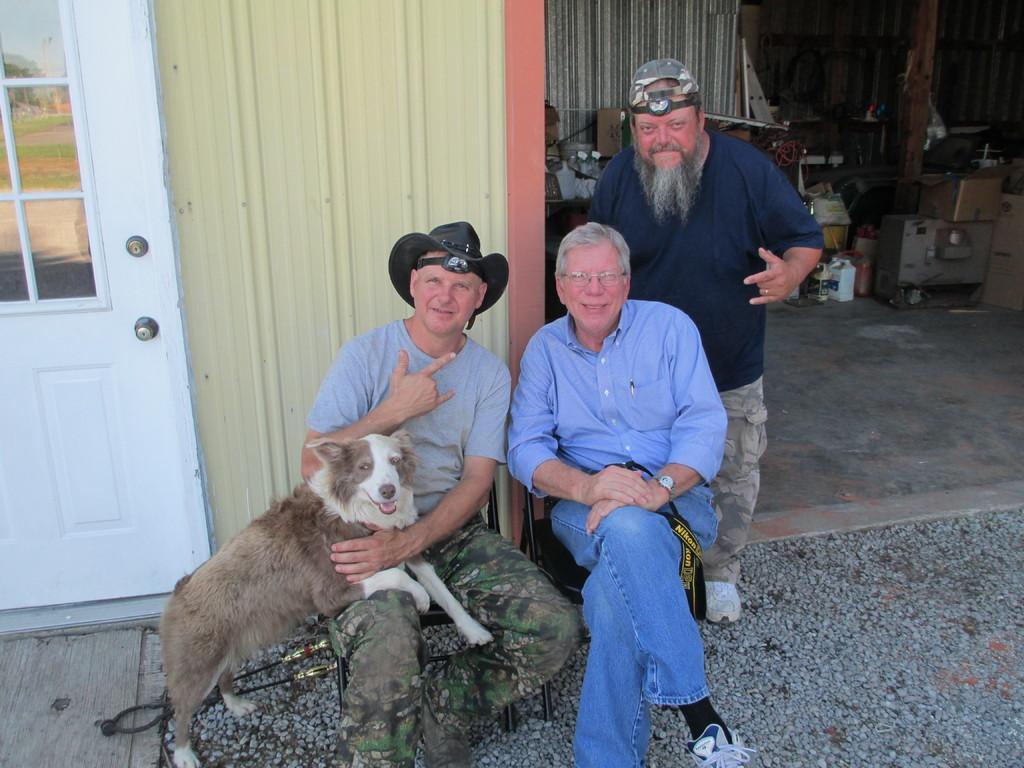Can you describe this image briefly? As we can see in the image there is a door, dog, three people. 